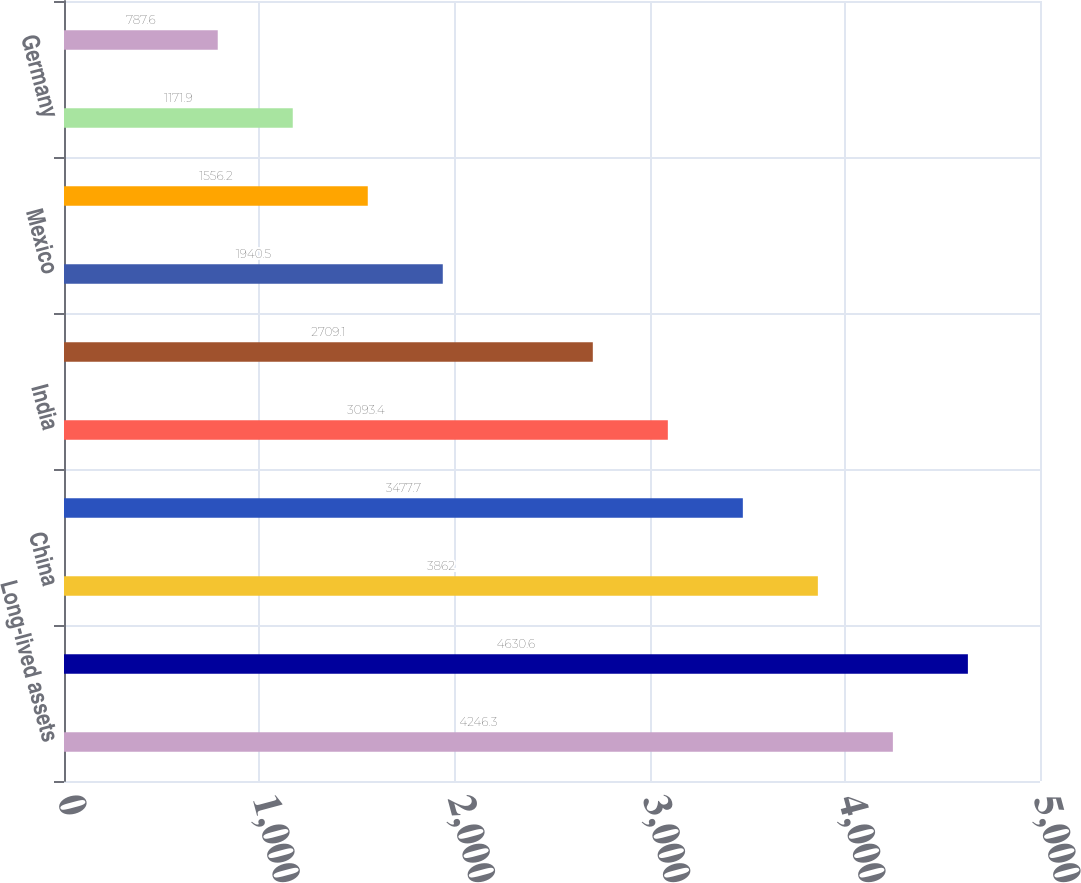Convert chart. <chart><loc_0><loc_0><loc_500><loc_500><bar_chart><fcel>Long-lived assets<fcel>United States<fcel>China<fcel>United Kingdom<fcel>India<fcel>Brazil<fcel>Mexico<fcel>Canada<fcel>Germany<fcel>Australia<nl><fcel>4246.3<fcel>4630.6<fcel>3862<fcel>3477.7<fcel>3093.4<fcel>2709.1<fcel>1940.5<fcel>1556.2<fcel>1171.9<fcel>787.6<nl></chart> 